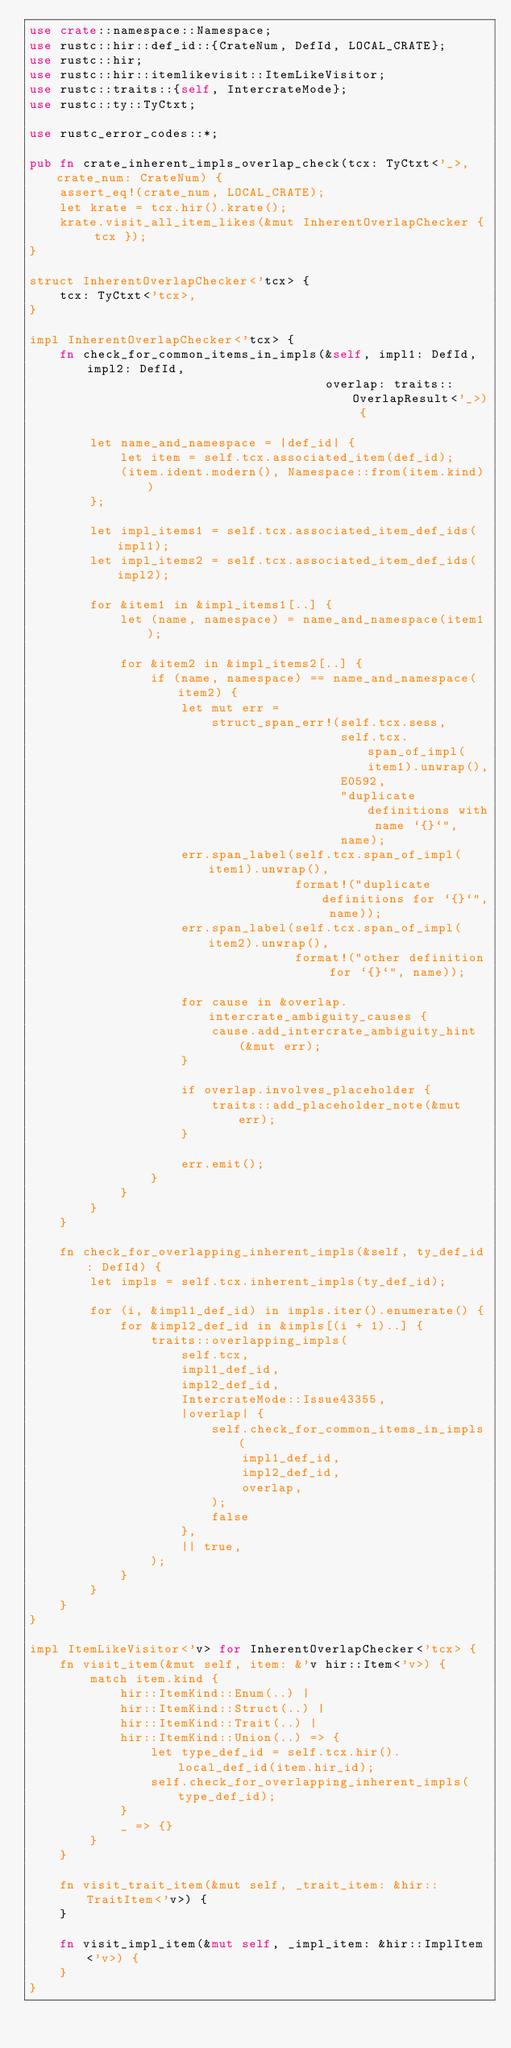Convert code to text. <code><loc_0><loc_0><loc_500><loc_500><_Rust_>use crate::namespace::Namespace;
use rustc::hir::def_id::{CrateNum, DefId, LOCAL_CRATE};
use rustc::hir;
use rustc::hir::itemlikevisit::ItemLikeVisitor;
use rustc::traits::{self, IntercrateMode};
use rustc::ty::TyCtxt;

use rustc_error_codes::*;

pub fn crate_inherent_impls_overlap_check(tcx: TyCtxt<'_>, crate_num: CrateNum) {
    assert_eq!(crate_num, LOCAL_CRATE);
    let krate = tcx.hir().krate();
    krate.visit_all_item_likes(&mut InherentOverlapChecker { tcx });
}

struct InherentOverlapChecker<'tcx> {
    tcx: TyCtxt<'tcx>,
}

impl InherentOverlapChecker<'tcx> {
    fn check_for_common_items_in_impls(&self, impl1: DefId, impl2: DefId,
                                       overlap: traits::OverlapResult<'_>) {

        let name_and_namespace = |def_id| {
            let item = self.tcx.associated_item(def_id);
            (item.ident.modern(), Namespace::from(item.kind))
        };

        let impl_items1 = self.tcx.associated_item_def_ids(impl1);
        let impl_items2 = self.tcx.associated_item_def_ids(impl2);

        for &item1 in &impl_items1[..] {
            let (name, namespace) = name_and_namespace(item1);

            for &item2 in &impl_items2[..] {
                if (name, namespace) == name_and_namespace(item2) {
                    let mut err =
                        struct_span_err!(self.tcx.sess,
                                         self.tcx.span_of_impl(item1).unwrap(),
                                         E0592,
                                         "duplicate definitions with name `{}`",
                                         name);
                    err.span_label(self.tcx.span_of_impl(item1).unwrap(),
                                   format!("duplicate definitions for `{}`", name));
                    err.span_label(self.tcx.span_of_impl(item2).unwrap(),
                                   format!("other definition for `{}`", name));

                    for cause in &overlap.intercrate_ambiguity_causes {
                        cause.add_intercrate_ambiguity_hint(&mut err);
                    }

                    if overlap.involves_placeholder {
                        traits::add_placeholder_note(&mut err);
                    }

                    err.emit();
                }
            }
        }
    }

    fn check_for_overlapping_inherent_impls(&self, ty_def_id: DefId) {
        let impls = self.tcx.inherent_impls(ty_def_id);

        for (i, &impl1_def_id) in impls.iter().enumerate() {
            for &impl2_def_id in &impls[(i + 1)..] {
                traits::overlapping_impls(
                    self.tcx,
                    impl1_def_id,
                    impl2_def_id,
                    IntercrateMode::Issue43355,
                    |overlap| {
                        self.check_for_common_items_in_impls(
                            impl1_def_id,
                            impl2_def_id,
                            overlap,
                        );
                        false
                    },
                    || true,
                );
            }
        }
    }
}

impl ItemLikeVisitor<'v> for InherentOverlapChecker<'tcx> {
    fn visit_item(&mut self, item: &'v hir::Item<'v>) {
        match item.kind {
            hir::ItemKind::Enum(..) |
            hir::ItemKind::Struct(..) |
            hir::ItemKind::Trait(..) |
            hir::ItemKind::Union(..) => {
                let type_def_id = self.tcx.hir().local_def_id(item.hir_id);
                self.check_for_overlapping_inherent_impls(type_def_id);
            }
            _ => {}
        }
    }

    fn visit_trait_item(&mut self, _trait_item: &hir::TraitItem<'v>) {
    }

    fn visit_impl_item(&mut self, _impl_item: &hir::ImplItem<'v>) {
    }
}
</code> 